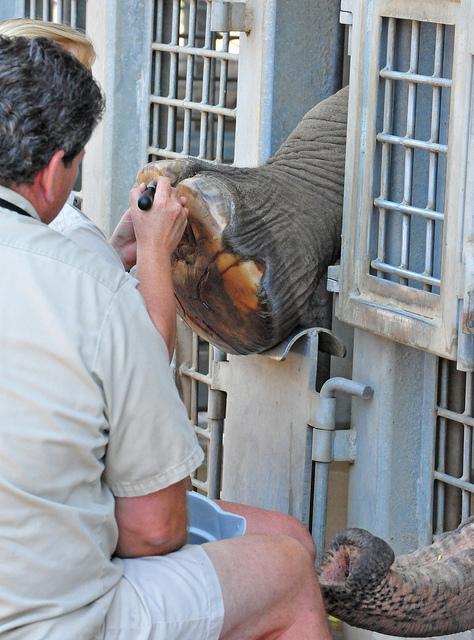What animal is the trainer working on?
Give a very brief answer. Elephant. Is the animal in a cage?
Concise answer only. Yes. What part of the animals is he working on?
Quick response, please. Foot. 